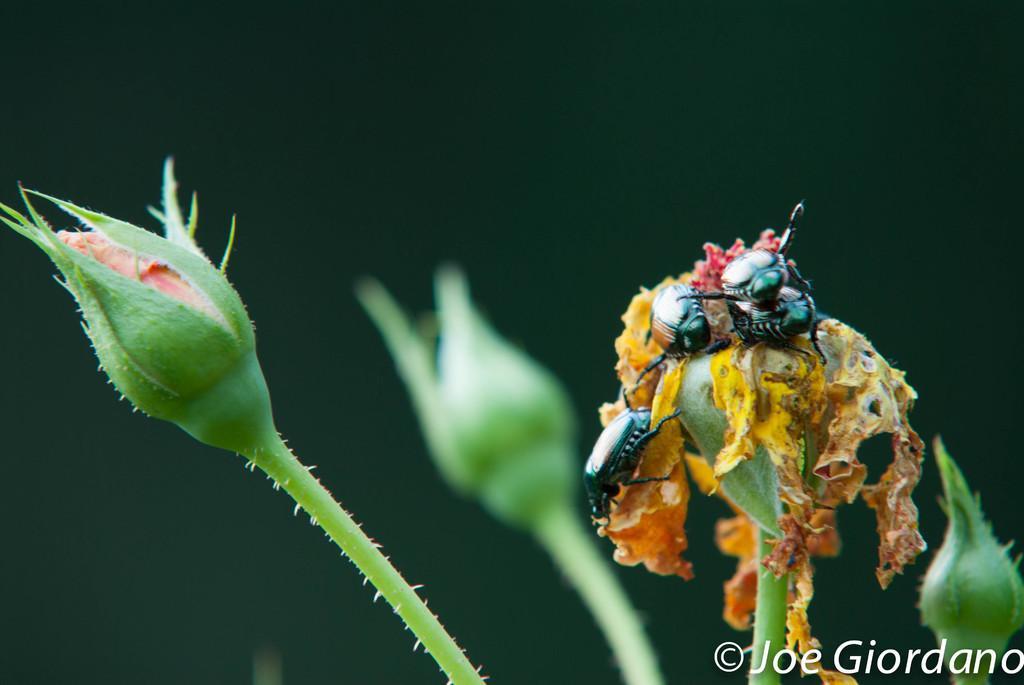Could you give a brief overview of what you see in this image? In the picture we can see there some flower buds and on the flower buds there are some bees. In the bottom right corner of the image we can see watermark. In the background it is dark. 